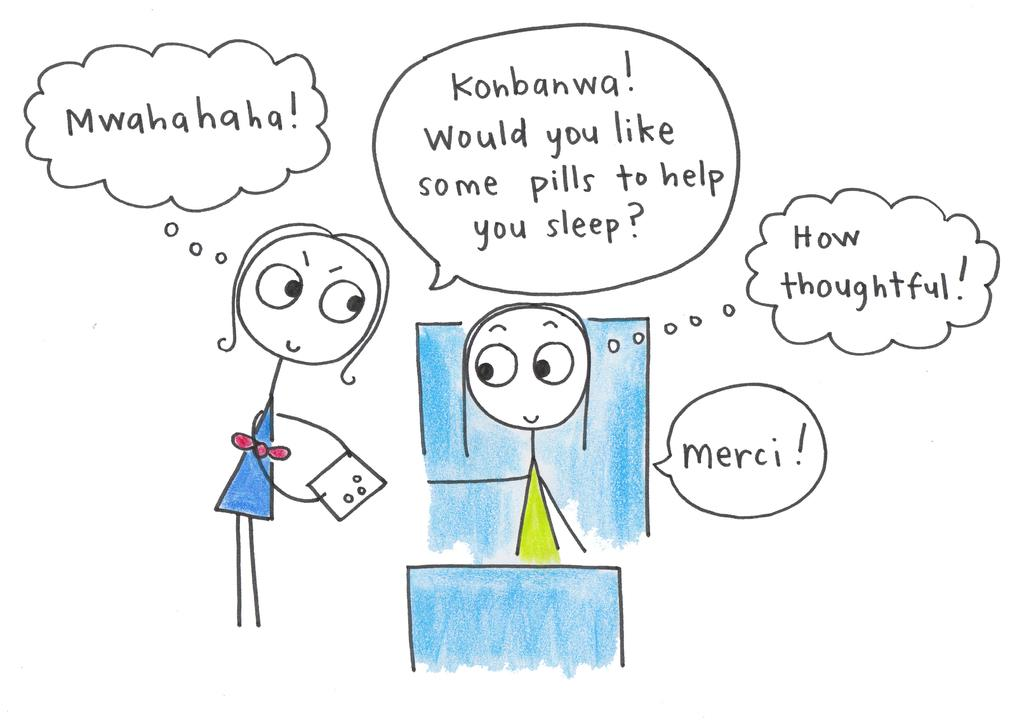What is the nature of the image? The image is a sketch. What are the people in the image doing? There is a person standing and holding an object, and another person is sitting. What can be found at the top of the image? There is text at the top of the image. What color is the background of the image? The background of the image is white. How many birds are nesting in the crowd in the image? There are no birds or crowds present in the image; it features a sketch of two people with a white background. 